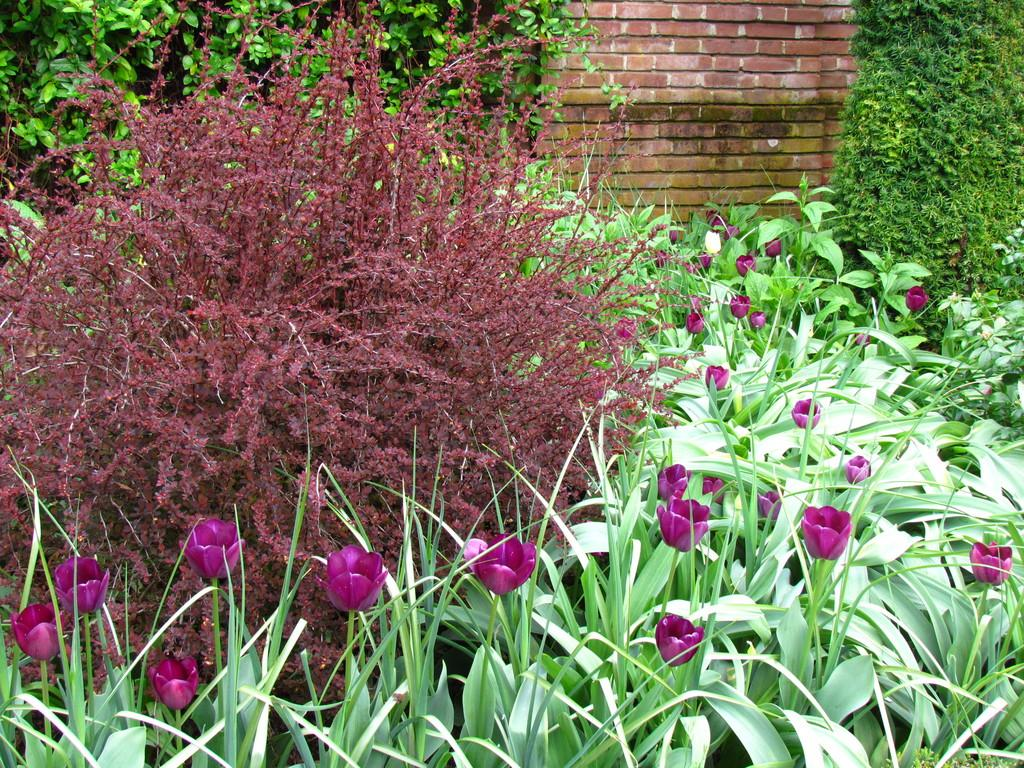Where was the picture taken? The picture was clicked outside. What can be seen in the foreground of the image? There are plants and flowers in the foreground of the image. What can be seen in the background of the image? There are green leaves and a brick wall in the background of the image. What grade did the actor receive for their performance in the image? There is no actor or performance present in the image, as it features plants, flowers, green leaves, and a brick wall. 